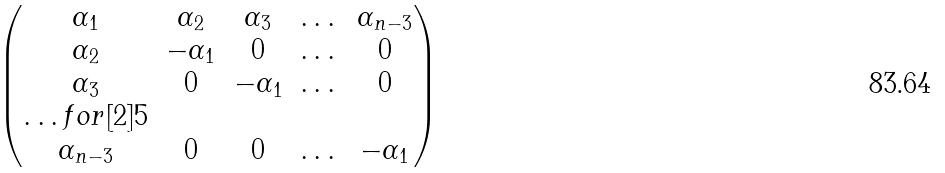<formula> <loc_0><loc_0><loc_500><loc_500>\begin{pmatrix} \alpha _ { 1 } & \alpha _ { 2 } & \alpha _ { 3 } & \dots & \alpha _ { n - 3 } \\ \alpha _ { 2 } & - \alpha _ { 1 } & 0 & \dots & 0 \\ \alpha _ { 3 } & 0 & - \alpha _ { 1 } & \dots & 0 \\ \hdots f o r [ 2 ] { 5 } \\ \alpha _ { n - 3 } & 0 & 0 & \dots & - \alpha _ { 1 } \end{pmatrix}</formula> 